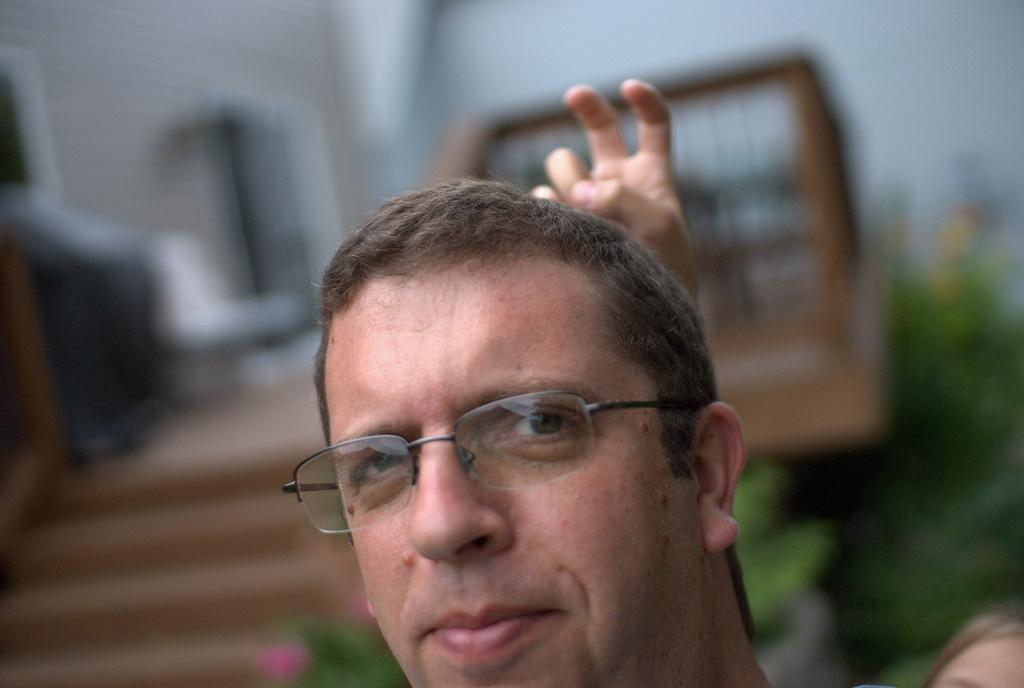What is the main subject of the image? There is a person's head in the image. Can you describe the background of the image? The background of the image is blurred. What type of fan can be seen in the image? There is no fan present in the image. Is there a jelly-like substance visible in the image? There is no jelly-like substance visible in the image. 